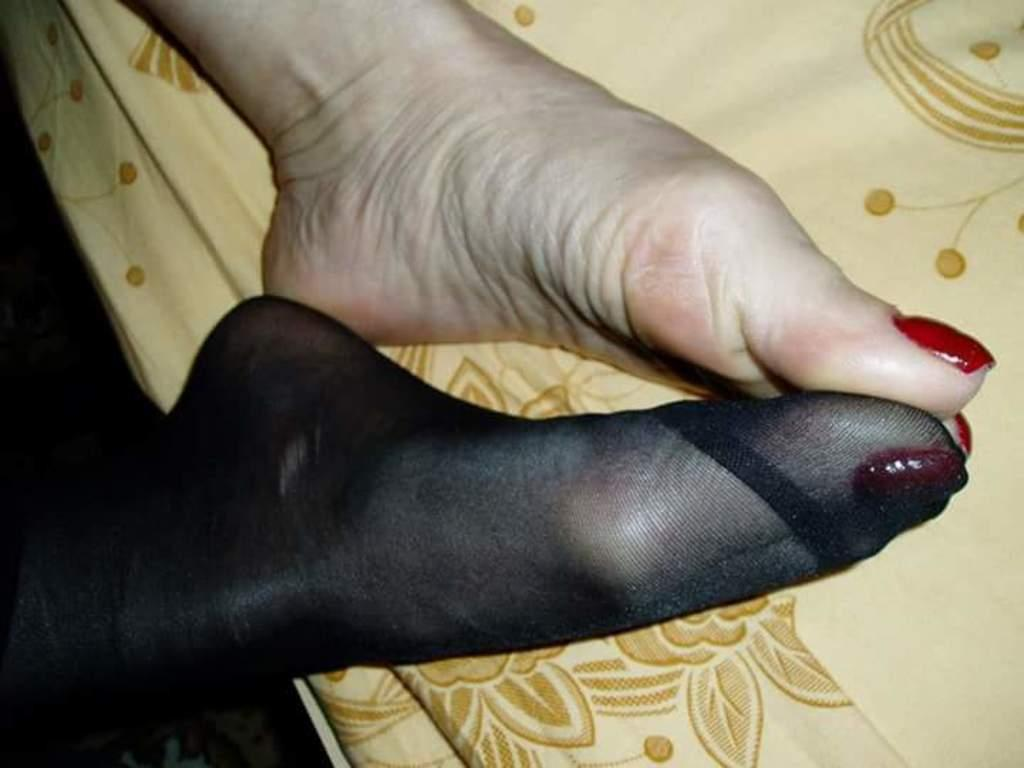What part of a person can be seen in the image? There are legs of a person visible in the image. What is covering the area below the person's legs? There is a blanket below the legs of the person. What type of needle is being used by the person in the image? There is no needle present in the image; it only shows the person's legs and a blanket. 